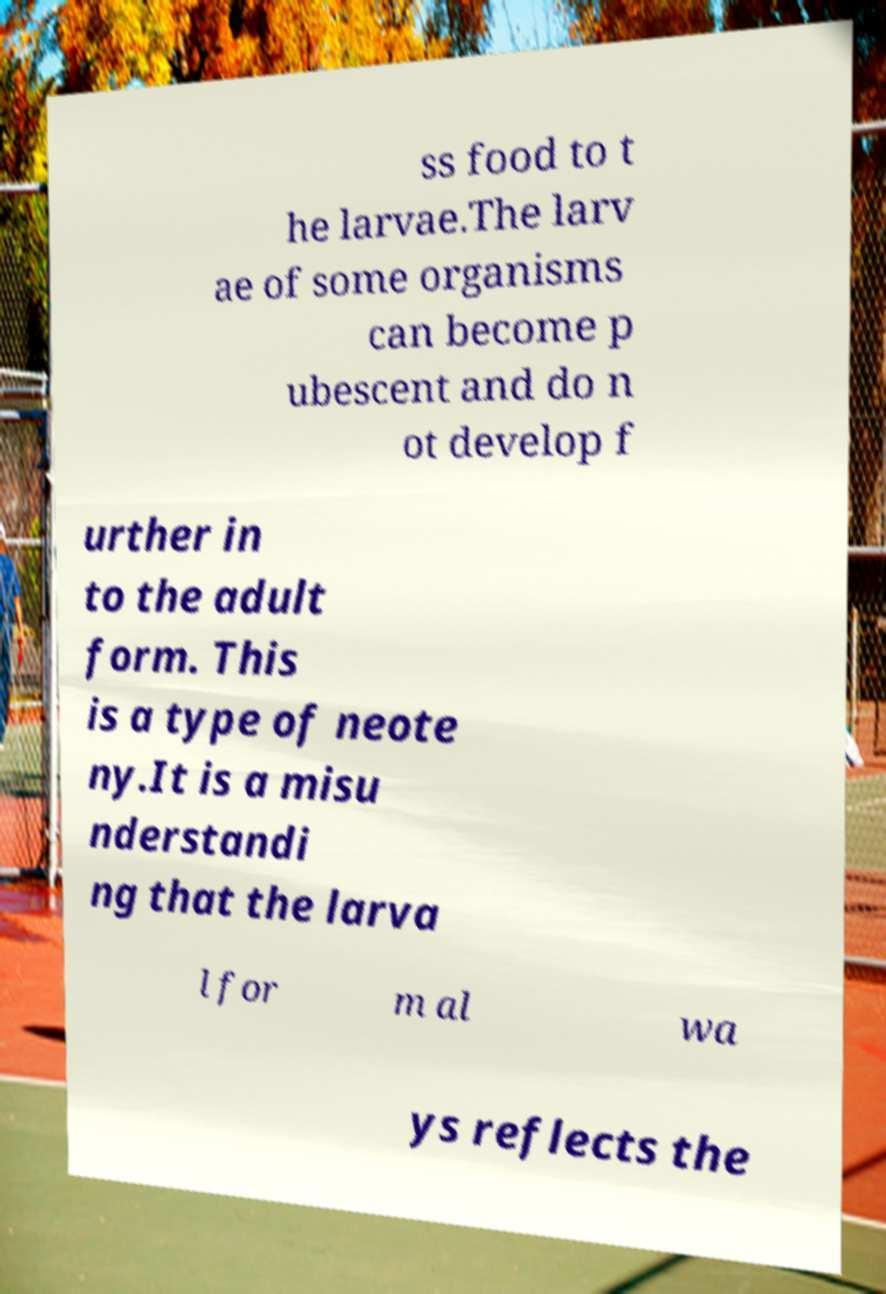Please identify and transcribe the text found in this image. ss food to t he larvae.The larv ae of some organisms can become p ubescent and do n ot develop f urther in to the adult form. This is a type of neote ny.It is a misu nderstandi ng that the larva l for m al wa ys reflects the 